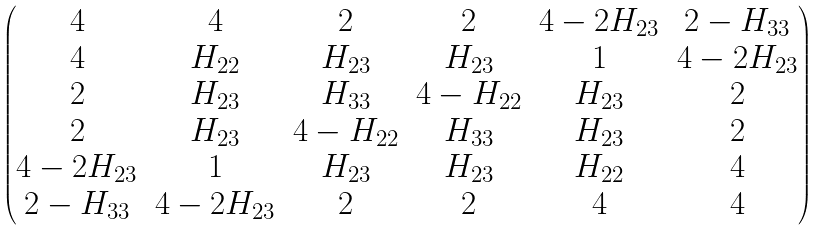<formula> <loc_0><loc_0><loc_500><loc_500>\begin{pmatrix} 4 & 4 & 2 & 2 & 4 - 2 H _ { 2 3 } & 2 - H _ { 3 3 } \\ 4 & H _ { 2 2 } & H _ { 2 3 } & H _ { 2 3 } & 1 & 4 - 2 H _ { 2 3 } \\ 2 & H _ { 2 3 } & H _ { 3 3 } & 4 - H _ { 2 2 } & H _ { 2 3 } & 2 \\ 2 & H _ { 2 3 } & 4 - H _ { 2 2 } & H _ { 3 3 } & H _ { 2 3 } & 2 \\ 4 - 2 H _ { 2 3 } & 1 & H _ { 2 3 } & H _ { 2 3 } & H _ { 2 2 } & 4 \\ 2 - H _ { 3 3 } & 4 - 2 H _ { 2 3 } & 2 & 2 & 4 & 4 \end{pmatrix}</formula> 